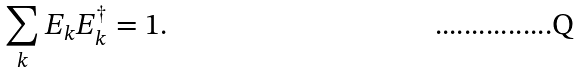<formula> <loc_0><loc_0><loc_500><loc_500>\sum _ { k } E _ { k } E _ { k } ^ { \dag } = 1 .</formula> 